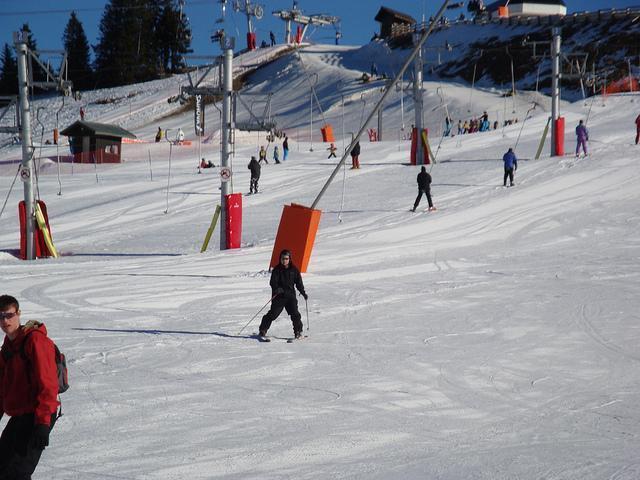How many people are there?
Give a very brief answer. 2. 